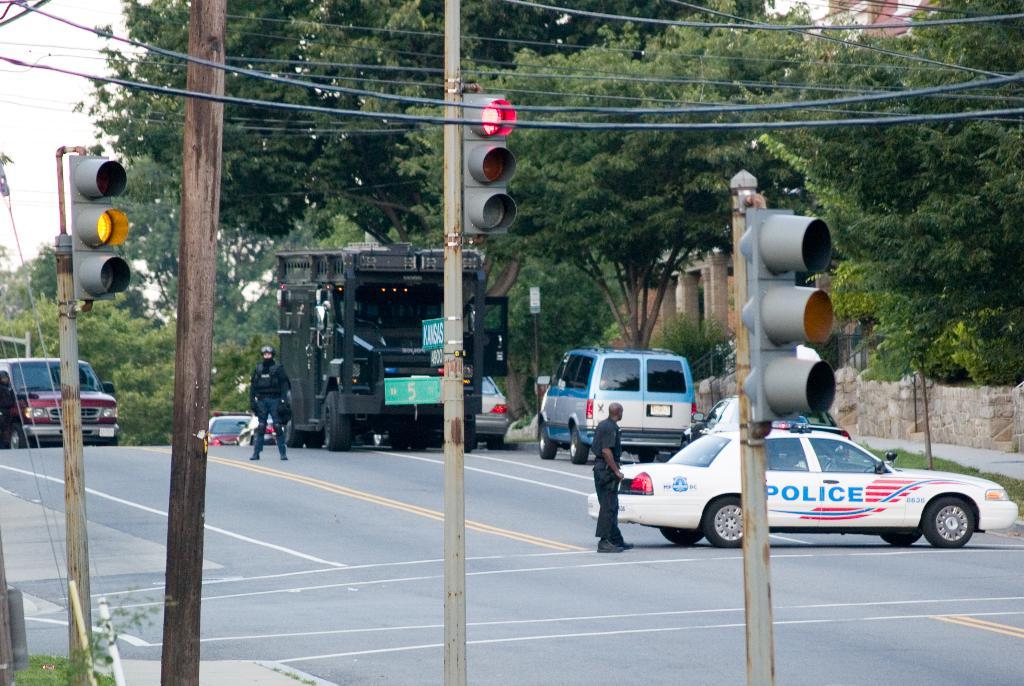What is written on the white car?
Keep it short and to the point. Police. What type of car?
Your answer should be very brief. Police. 